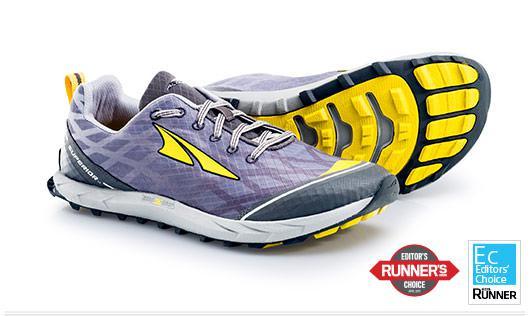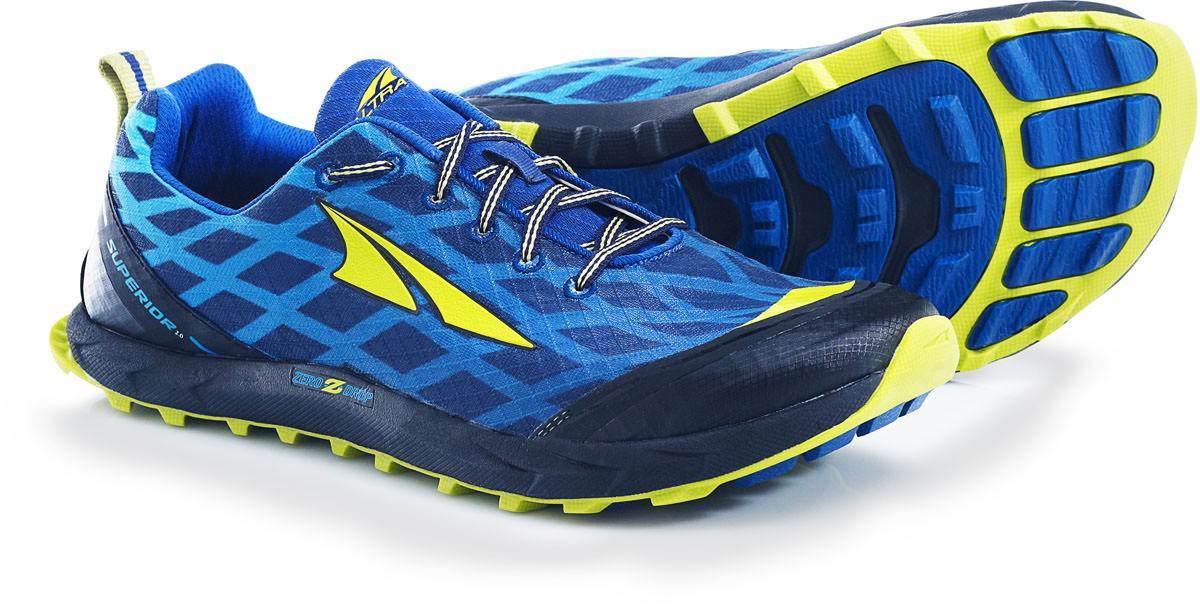The first image is the image on the left, the second image is the image on the right. Considering the images on both sides, is "Each image contains only one pair of shoes, and each pair is displayed with one shoe in front of a shoe turned on its side." valid? Answer yes or no. Yes. The first image is the image on the left, the second image is the image on the right. For the images displayed, is the sentence "Two pairs of shoes, each laced with coordinating laces, are shown with one shoe sideways and the other shoe laying behind it with a colorful sole showing." factually correct? Answer yes or no. Yes. 